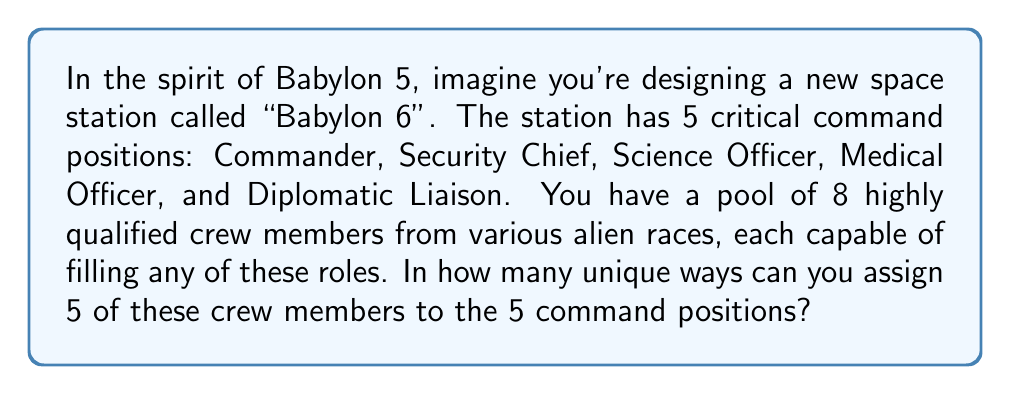Help me with this question. This problem is a perfect application of permutations. Here's how we can break it down:

1) First, we need to select 5 crew members out of the 8 available. This is a combination problem.

2) Once we have selected 5 crew members, we need to arrange them in the 5 positions. This is a permutation.

Let's solve this step-by-step:

1) Selecting 5 crew members out of 8:
   This is given by the combination formula: $${8 \choose 5} = \frac{8!}{5!(8-5)!} = \frac{8!}{5!3!}$$

2) Arranging 5 crew members in 5 positions:
   This is a straightforward permutation of 5 elements, which is simply 5!

3) By the multiplication principle, we multiply these two values:

   $${8 \choose 5} \times 5!$$

4) Let's calculate:
   $${8 \choose 5} = \frac{8!}{5!3!} = \frac{40320}{120 \times 6} = 56$$
   
   $$56 \times 5! = 56 \times 120 = 6720$$

Therefore, there are 6720 unique ways to assign the crew members to the command positions.

This large number of possibilities reflects the diversity and adaptability of crews in science fiction series like Babylon 5, where characters from different species and backgrounds come together to form effective teams.
Answer: 6720 unique ways 